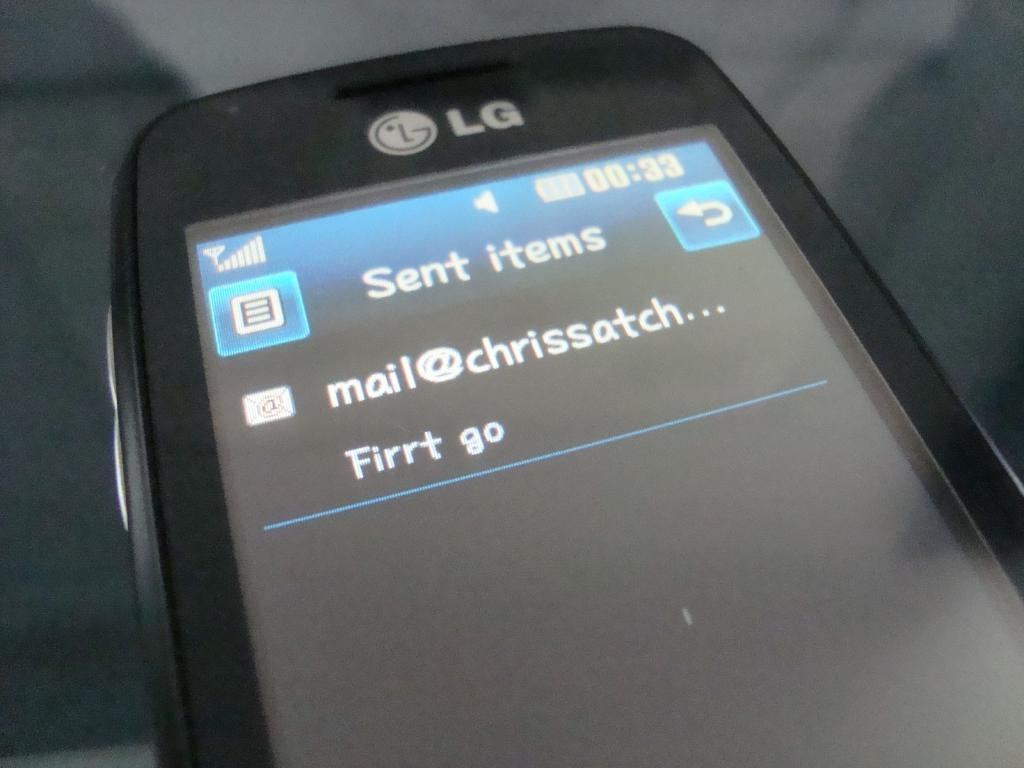What object is the main subject of the image? There is a mobile in the image. What can be seen on the mobile screen? There is text on the mobile screen. Can you describe the background of the image? The background of the image is blurred. What type of cub is visible in the aftermath of the event in the image? There is no cub or event present in the image; it only features a mobile with text on the screen and a blurred background. 